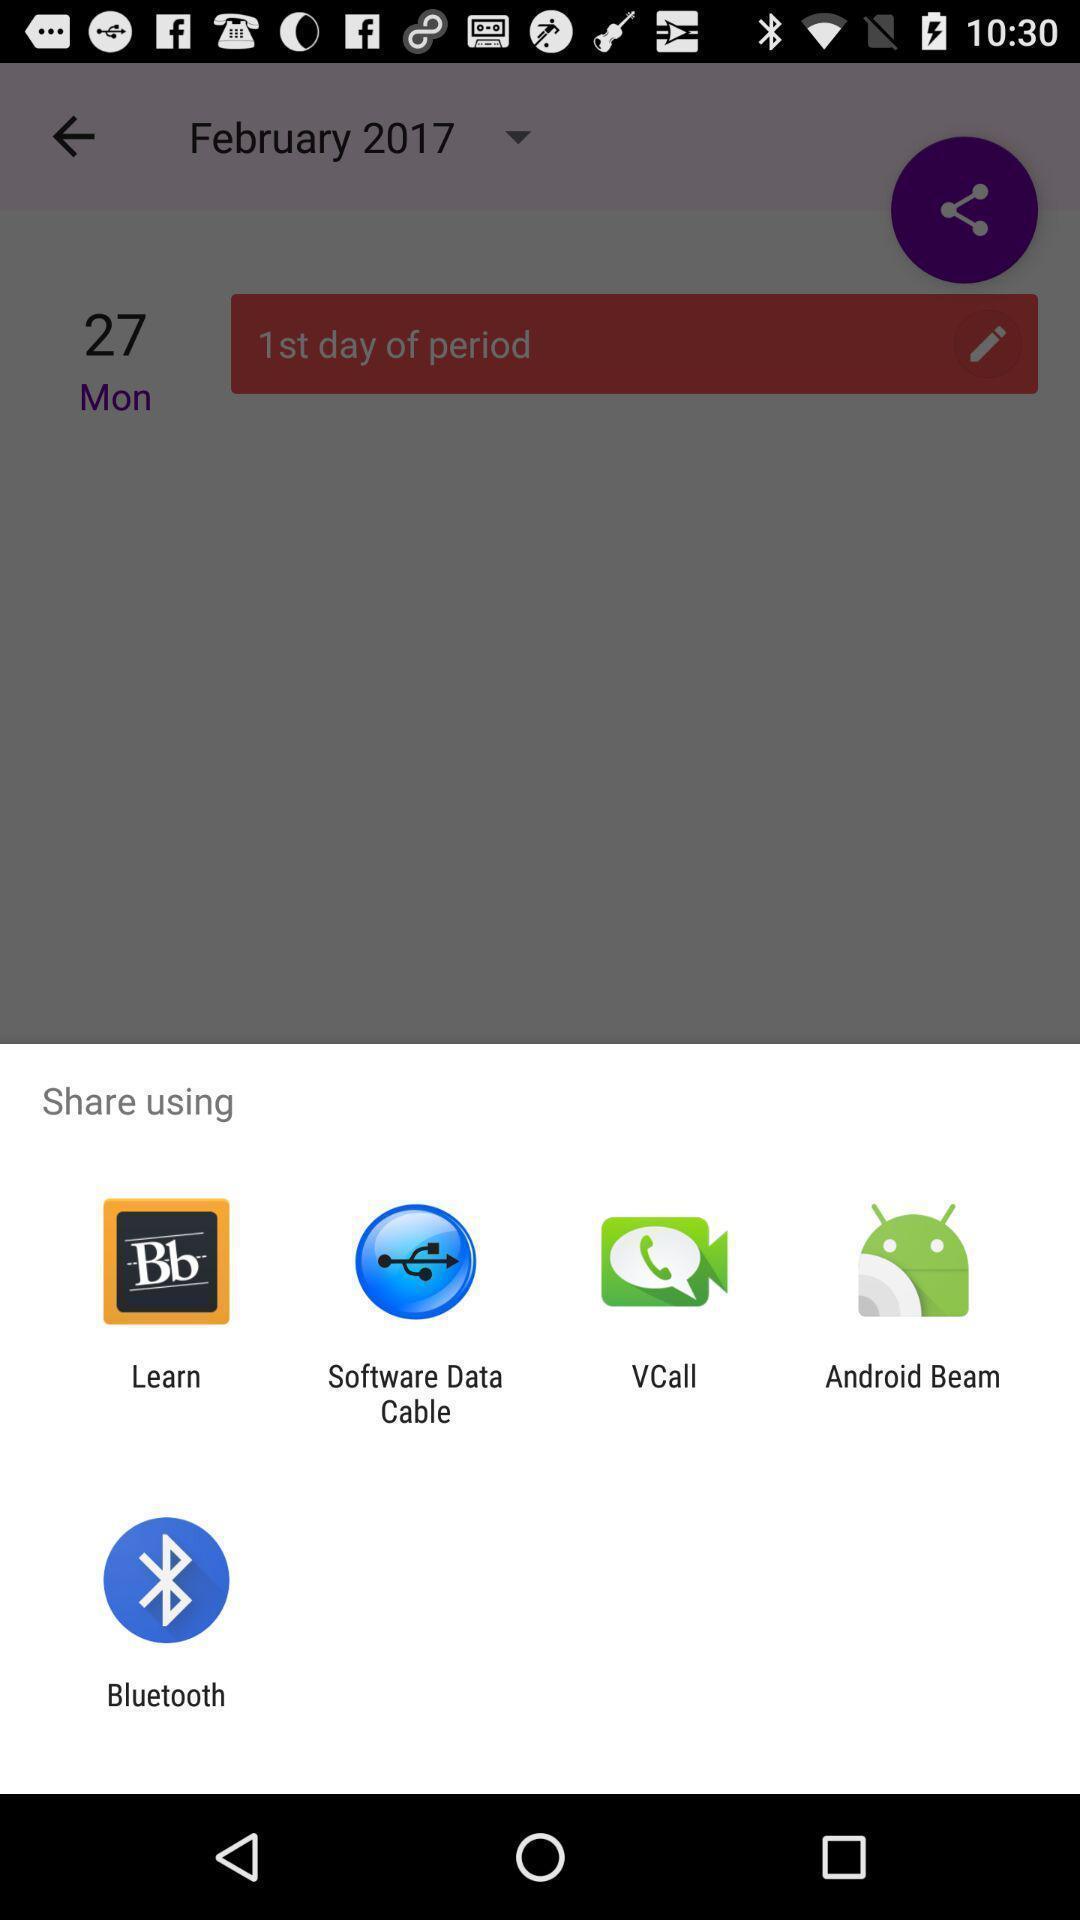Describe this image in words. Pop-up shows share option with multiple applications. 